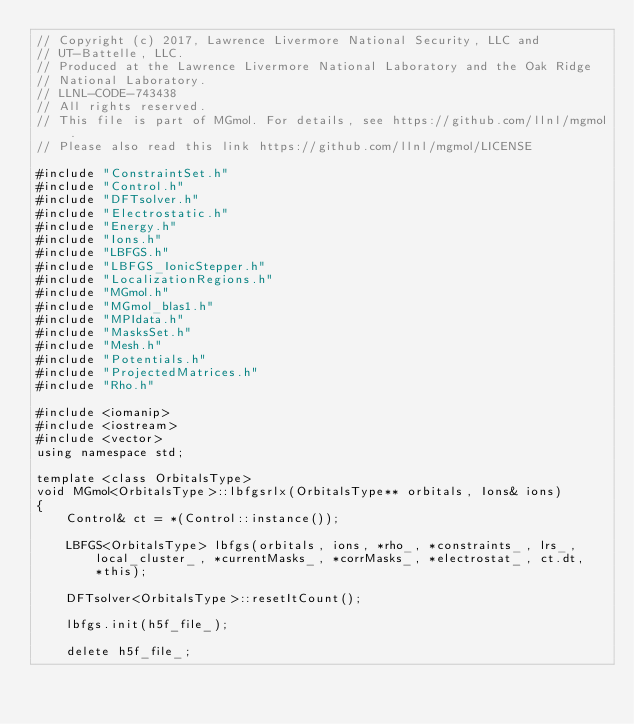<code> <loc_0><loc_0><loc_500><loc_500><_C++_>// Copyright (c) 2017, Lawrence Livermore National Security, LLC and
// UT-Battelle, LLC.
// Produced at the Lawrence Livermore National Laboratory and the Oak Ridge
// National Laboratory.
// LLNL-CODE-743438
// All rights reserved.
// This file is part of MGmol. For details, see https://github.com/llnl/mgmol.
// Please also read this link https://github.com/llnl/mgmol/LICENSE

#include "ConstraintSet.h"
#include "Control.h"
#include "DFTsolver.h"
#include "Electrostatic.h"
#include "Energy.h"
#include "Ions.h"
#include "LBFGS.h"
#include "LBFGS_IonicStepper.h"
#include "LocalizationRegions.h"
#include "MGmol.h"
#include "MGmol_blas1.h"
#include "MPIdata.h"
#include "MasksSet.h"
#include "Mesh.h"
#include "Potentials.h"
#include "ProjectedMatrices.h"
#include "Rho.h"

#include <iomanip>
#include <iostream>
#include <vector>
using namespace std;

template <class OrbitalsType>
void MGmol<OrbitalsType>::lbfgsrlx(OrbitalsType** orbitals, Ions& ions)
{
    Control& ct = *(Control::instance());

    LBFGS<OrbitalsType> lbfgs(orbitals, ions, *rho_, *constraints_, lrs_,
        local_cluster_, *currentMasks_, *corrMasks_, *electrostat_, ct.dt,
        *this);

    DFTsolver<OrbitalsType>::resetItCount();

    lbfgs.init(h5f_file_);

    delete h5f_file_;</code> 